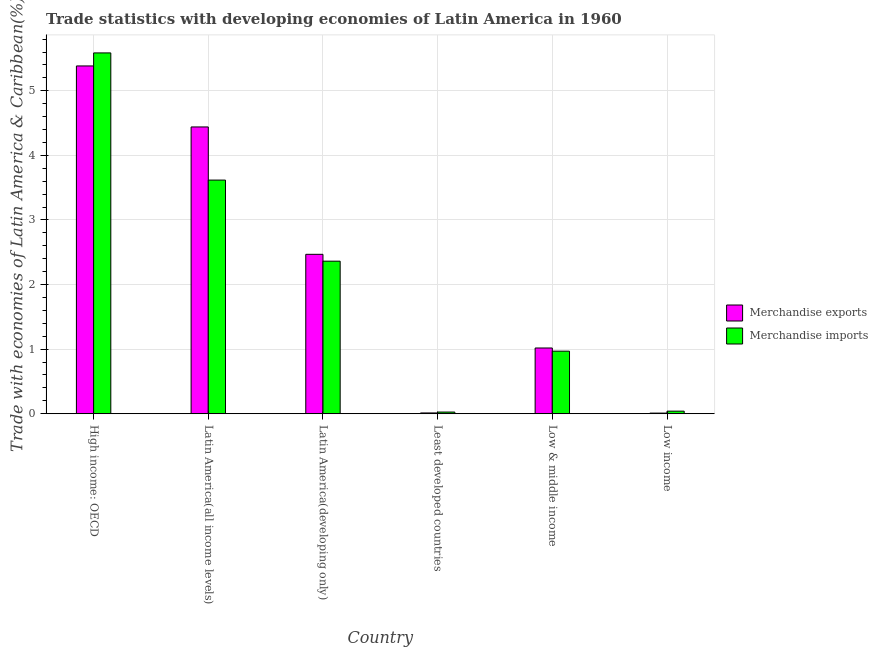Are the number of bars on each tick of the X-axis equal?
Provide a short and direct response. Yes. What is the label of the 5th group of bars from the left?
Your answer should be very brief. Low & middle income. In how many cases, is the number of bars for a given country not equal to the number of legend labels?
Give a very brief answer. 0. What is the merchandise imports in Least developed countries?
Offer a very short reply. 0.03. Across all countries, what is the maximum merchandise exports?
Your answer should be very brief. 5.38. Across all countries, what is the minimum merchandise imports?
Offer a terse response. 0.03. In which country was the merchandise imports maximum?
Your response must be concise. High income: OECD. In which country was the merchandise imports minimum?
Your response must be concise. Least developed countries. What is the total merchandise exports in the graph?
Provide a succinct answer. 13.33. What is the difference between the merchandise exports in Least developed countries and that in Low & middle income?
Your response must be concise. -1.01. What is the difference between the merchandise imports in Low income and the merchandise exports in Low & middle income?
Your answer should be very brief. -0.98. What is the average merchandise imports per country?
Make the answer very short. 2.1. What is the difference between the merchandise imports and merchandise exports in Low & middle income?
Ensure brevity in your answer.  -0.05. What is the ratio of the merchandise exports in Latin America(all income levels) to that in Low income?
Offer a very short reply. 452.83. Is the difference between the merchandise exports in Latin America(all income levels) and Least developed countries greater than the difference between the merchandise imports in Latin America(all income levels) and Least developed countries?
Your response must be concise. Yes. What is the difference between the highest and the second highest merchandise imports?
Provide a succinct answer. 1.97. What is the difference between the highest and the lowest merchandise exports?
Offer a terse response. 5.37. Is the sum of the merchandise exports in High income: OECD and Least developed countries greater than the maximum merchandise imports across all countries?
Your response must be concise. No. What does the 1st bar from the right in Low income represents?
Offer a terse response. Merchandise imports. What is the difference between two consecutive major ticks on the Y-axis?
Your answer should be compact. 1. Where does the legend appear in the graph?
Keep it short and to the point. Center right. How many legend labels are there?
Offer a very short reply. 2. What is the title of the graph?
Give a very brief answer. Trade statistics with developing economies of Latin America in 1960. What is the label or title of the X-axis?
Provide a short and direct response. Country. What is the label or title of the Y-axis?
Offer a terse response. Trade with economies of Latin America & Caribbean(%). What is the Trade with economies of Latin America & Caribbean(%) in Merchandise exports in High income: OECD?
Give a very brief answer. 5.38. What is the Trade with economies of Latin America & Caribbean(%) of Merchandise imports in High income: OECD?
Your answer should be compact. 5.59. What is the Trade with economies of Latin America & Caribbean(%) in Merchandise exports in Latin America(all income levels)?
Your answer should be compact. 4.44. What is the Trade with economies of Latin America & Caribbean(%) in Merchandise imports in Latin America(all income levels)?
Your response must be concise. 3.62. What is the Trade with economies of Latin America & Caribbean(%) of Merchandise exports in Latin America(developing only)?
Your answer should be very brief. 2.47. What is the Trade with economies of Latin America & Caribbean(%) in Merchandise imports in Latin America(developing only)?
Offer a very short reply. 2.36. What is the Trade with economies of Latin America & Caribbean(%) of Merchandise exports in Least developed countries?
Keep it short and to the point. 0.01. What is the Trade with economies of Latin America & Caribbean(%) of Merchandise imports in Least developed countries?
Make the answer very short. 0.03. What is the Trade with economies of Latin America & Caribbean(%) in Merchandise exports in Low & middle income?
Ensure brevity in your answer.  1.02. What is the Trade with economies of Latin America & Caribbean(%) of Merchandise imports in Low & middle income?
Provide a short and direct response. 0.97. What is the Trade with economies of Latin America & Caribbean(%) of Merchandise exports in Low income?
Keep it short and to the point. 0.01. What is the Trade with economies of Latin America & Caribbean(%) of Merchandise imports in Low income?
Offer a terse response. 0.04. Across all countries, what is the maximum Trade with economies of Latin America & Caribbean(%) in Merchandise exports?
Your answer should be very brief. 5.38. Across all countries, what is the maximum Trade with economies of Latin America & Caribbean(%) in Merchandise imports?
Provide a succinct answer. 5.59. Across all countries, what is the minimum Trade with economies of Latin America & Caribbean(%) in Merchandise exports?
Provide a short and direct response. 0.01. Across all countries, what is the minimum Trade with economies of Latin America & Caribbean(%) in Merchandise imports?
Your answer should be compact. 0.03. What is the total Trade with economies of Latin America & Caribbean(%) of Merchandise exports in the graph?
Your response must be concise. 13.33. What is the total Trade with economies of Latin America & Caribbean(%) in Merchandise imports in the graph?
Ensure brevity in your answer.  12.6. What is the difference between the Trade with economies of Latin America & Caribbean(%) of Merchandise exports in High income: OECD and that in Latin America(all income levels)?
Offer a very short reply. 0.94. What is the difference between the Trade with economies of Latin America & Caribbean(%) in Merchandise imports in High income: OECD and that in Latin America(all income levels)?
Provide a short and direct response. 1.97. What is the difference between the Trade with economies of Latin America & Caribbean(%) of Merchandise exports in High income: OECD and that in Latin America(developing only)?
Give a very brief answer. 2.92. What is the difference between the Trade with economies of Latin America & Caribbean(%) in Merchandise imports in High income: OECD and that in Latin America(developing only)?
Provide a short and direct response. 3.22. What is the difference between the Trade with economies of Latin America & Caribbean(%) in Merchandise exports in High income: OECD and that in Least developed countries?
Provide a short and direct response. 5.37. What is the difference between the Trade with economies of Latin America & Caribbean(%) in Merchandise imports in High income: OECD and that in Least developed countries?
Ensure brevity in your answer.  5.56. What is the difference between the Trade with economies of Latin America & Caribbean(%) in Merchandise exports in High income: OECD and that in Low & middle income?
Your answer should be compact. 4.37. What is the difference between the Trade with economies of Latin America & Caribbean(%) in Merchandise imports in High income: OECD and that in Low & middle income?
Ensure brevity in your answer.  4.62. What is the difference between the Trade with economies of Latin America & Caribbean(%) in Merchandise exports in High income: OECD and that in Low income?
Give a very brief answer. 5.37. What is the difference between the Trade with economies of Latin America & Caribbean(%) in Merchandise imports in High income: OECD and that in Low income?
Offer a very short reply. 5.55. What is the difference between the Trade with economies of Latin America & Caribbean(%) in Merchandise exports in Latin America(all income levels) and that in Latin America(developing only)?
Your answer should be very brief. 1.97. What is the difference between the Trade with economies of Latin America & Caribbean(%) in Merchandise imports in Latin America(all income levels) and that in Latin America(developing only)?
Your answer should be very brief. 1.26. What is the difference between the Trade with economies of Latin America & Caribbean(%) of Merchandise exports in Latin America(all income levels) and that in Least developed countries?
Offer a terse response. 4.43. What is the difference between the Trade with economies of Latin America & Caribbean(%) of Merchandise imports in Latin America(all income levels) and that in Least developed countries?
Ensure brevity in your answer.  3.59. What is the difference between the Trade with economies of Latin America & Caribbean(%) of Merchandise exports in Latin America(all income levels) and that in Low & middle income?
Your response must be concise. 3.42. What is the difference between the Trade with economies of Latin America & Caribbean(%) in Merchandise imports in Latin America(all income levels) and that in Low & middle income?
Offer a very short reply. 2.65. What is the difference between the Trade with economies of Latin America & Caribbean(%) in Merchandise exports in Latin America(all income levels) and that in Low income?
Provide a short and direct response. 4.43. What is the difference between the Trade with economies of Latin America & Caribbean(%) of Merchandise imports in Latin America(all income levels) and that in Low income?
Your answer should be compact. 3.58. What is the difference between the Trade with economies of Latin America & Caribbean(%) in Merchandise exports in Latin America(developing only) and that in Least developed countries?
Your response must be concise. 2.46. What is the difference between the Trade with economies of Latin America & Caribbean(%) in Merchandise imports in Latin America(developing only) and that in Least developed countries?
Give a very brief answer. 2.34. What is the difference between the Trade with economies of Latin America & Caribbean(%) of Merchandise exports in Latin America(developing only) and that in Low & middle income?
Your answer should be very brief. 1.45. What is the difference between the Trade with economies of Latin America & Caribbean(%) of Merchandise imports in Latin America(developing only) and that in Low & middle income?
Your answer should be compact. 1.39. What is the difference between the Trade with economies of Latin America & Caribbean(%) of Merchandise exports in Latin America(developing only) and that in Low income?
Your answer should be compact. 2.46. What is the difference between the Trade with economies of Latin America & Caribbean(%) of Merchandise imports in Latin America(developing only) and that in Low income?
Offer a very short reply. 2.32. What is the difference between the Trade with economies of Latin America & Caribbean(%) of Merchandise exports in Least developed countries and that in Low & middle income?
Your response must be concise. -1.01. What is the difference between the Trade with economies of Latin America & Caribbean(%) in Merchandise imports in Least developed countries and that in Low & middle income?
Make the answer very short. -0.94. What is the difference between the Trade with economies of Latin America & Caribbean(%) in Merchandise exports in Least developed countries and that in Low income?
Provide a succinct answer. 0. What is the difference between the Trade with economies of Latin America & Caribbean(%) of Merchandise imports in Least developed countries and that in Low income?
Offer a very short reply. -0.01. What is the difference between the Trade with economies of Latin America & Caribbean(%) in Merchandise imports in Low & middle income and that in Low income?
Make the answer very short. 0.93. What is the difference between the Trade with economies of Latin America & Caribbean(%) in Merchandise exports in High income: OECD and the Trade with economies of Latin America & Caribbean(%) in Merchandise imports in Latin America(all income levels)?
Your response must be concise. 1.77. What is the difference between the Trade with economies of Latin America & Caribbean(%) in Merchandise exports in High income: OECD and the Trade with economies of Latin America & Caribbean(%) in Merchandise imports in Latin America(developing only)?
Give a very brief answer. 3.02. What is the difference between the Trade with economies of Latin America & Caribbean(%) in Merchandise exports in High income: OECD and the Trade with economies of Latin America & Caribbean(%) in Merchandise imports in Least developed countries?
Make the answer very short. 5.36. What is the difference between the Trade with economies of Latin America & Caribbean(%) in Merchandise exports in High income: OECD and the Trade with economies of Latin America & Caribbean(%) in Merchandise imports in Low & middle income?
Offer a very short reply. 4.42. What is the difference between the Trade with economies of Latin America & Caribbean(%) in Merchandise exports in High income: OECD and the Trade with economies of Latin America & Caribbean(%) in Merchandise imports in Low income?
Your response must be concise. 5.34. What is the difference between the Trade with economies of Latin America & Caribbean(%) of Merchandise exports in Latin America(all income levels) and the Trade with economies of Latin America & Caribbean(%) of Merchandise imports in Latin America(developing only)?
Offer a very short reply. 2.08. What is the difference between the Trade with economies of Latin America & Caribbean(%) of Merchandise exports in Latin America(all income levels) and the Trade with economies of Latin America & Caribbean(%) of Merchandise imports in Least developed countries?
Your response must be concise. 4.41. What is the difference between the Trade with economies of Latin America & Caribbean(%) of Merchandise exports in Latin America(all income levels) and the Trade with economies of Latin America & Caribbean(%) of Merchandise imports in Low & middle income?
Give a very brief answer. 3.47. What is the difference between the Trade with economies of Latin America & Caribbean(%) of Merchandise exports in Latin America(all income levels) and the Trade with economies of Latin America & Caribbean(%) of Merchandise imports in Low income?
Offer a terse response. 4.4. What is the difference between the Trade with economies of Latin America & Caribbean(%) in Merchandise exports in Latin America(developing only) and the Trade with economies of Latin America & Caribbean(%) in Merchandise imports in Least developed countries?
Your response must be concise. 2.44. What is the difference between the Trade with economies of Latin America & Caribbean(%) in Merchandise exports in Latin America(developing only) and the Trade with economies of Latin America & Caribbean(%) in Merchandise imports in Low & middle income?
Provide a short and direct response. 1.5. What is the difference between the Trade with economies of Latin America & Caribbean(%) of Merchandise exports in Latin America(developing only) and the Trade with economies of Latin America & Caribbean(%) of Merchandise imports in Low income?
Give a very brief answer. 2.43. What is the difference between the Trade with economies of Latin America & Caribbean(%) in Merchandise exports in Least developed countries and the Trade with economies of Latin America & Caribbean(%) in Merchandise imports in Low & middle income?
Give a very brief answer. -0.96. What is the difference between the Trade with economies of Latin America & Caribbean(%) in Merchandise exports in Least developed countries and the Trade with economies of Latin America & Caribbean(%) in Merchandise imports in Low income?
Keep it short and to the point. -0.03. What is the difference between the Trade with economies of Latin America & Caribbean(%) of Merchandise exports in Low & middle income and the Trade with economies of Latin America & Caribbean(%) of Merchandise imports in Low income?
Offer a very short reply. 0.98. What is the average Trade with economies of Latin America & Caribbean(%) in Merchandise exports per country?
Your answer should be very brief. 2.22. What is the difference between the Trade with economies of Latin America & Caribbean(%) of Merchandise exports and Trade with economies of Latin America & Caribbean(%) of Merchandise imports in High income: OECD?
Offer a terse response. -0.2. What is the difference between the Trade with economies of Latin America & Caribbean(%) in Merchandise exports and Trade with economies of Latin America & Caribbean(%) in Merchandise imports in Latin America(all income levels)?
Provide a succinct answer. 0.82. What is the difference between the Trade with economies of Latin America & Caribbean(%) of Merchandise exports and Trade with economies of Latin America & Caribbean(%) of Merchandise imports in Latin America(developing only)?
Your answer should be compact. 0.11. What is the difference between the Trade with economies of Latin America & Caribbean(%) of Merchandise exports and Trade with economies of Latin America & Caribbean(%) of Merchandise imports in Least developed countries?
Ensure brevity in your answer.  -0.01. What is the difference between the Trade with economies of Latin America & Caribbean(%) in Merchandise exports and Trade with economies of Latin America & Caribbean(%) in Merchandise imports in Low & middle income?
Keep it short and to the point. 0.05. What is the difference between the Trade with economies of Latin America & Caribbean(%) in Merchandise exports and Trade with economies of Latin America & Caribbean(%) in Merchandise imports in Low income?
Your answer should be very brief. -0.03. What is the ratio of the Trade with economies of Latin America & Caribbean(%) of Merchandise exports in High income: OECD to that in Latin America(all income levels)?
Provide a succinct answer. 1.21. What is the ratio of the Trade with economies of Latin America & Caribbean(%) in Merchandise imports in High income: OECD to that in Latin America(all income levels)?
Keep it short and to the point. 1.54. What is the ratio of the Trade with economies of Latin America & Caribbean(%) in Merchandise exports in High income: OECD to that in Latin America(developing only)?
Provide a succinct answer. 2.18. What is the ratio of the Trade with economies of Latin America & Caribbean(%) of Merchandise imports in High income: OECD to that in Latin America(developing only)?
Offer a very short reply. 2.37. What is the ratio of the Trade with economies of Latin America & Caribbean(%) in Merchandise exports in High income: OECD to that in Least developed countries?
Your answer should be very brief. 436.17. What is the ratio of the Trade with economies of Latin America & Caribbean(%) of Merchandise imports in High income: OECD to that in Least developed countries?
Your response must be concise. 214.16. What is the ratio of the Trade with economies of Latin America & Caribbean(%) of Merchandise exports in High income: OECD to that in Low & middle income?
Your answer should be compact. 5.29. What is the ratio of the Trade with economies of Latin America & Caribbean(%) of Merchandise imports in High income: OECD to that in Low & middle income?
Ensure brevity in your answer.  5.77. What is the ratio of the Trade with economies of Latin America & Caribbean(%) of Merchandise exports in High income: OECD to that in Low income?
Provide a succinct answer. 549.16. What is the ratio of the Trade with economies of Latin America & Caribbean(%) in Merchandise imports in High income: OECD to that in Low income?
Your response must be concise. 138.92. What is the ratio of the Trade with economies of Latin America & Caribbean(%) in Merchandise exports in Latin America(all income levels) to that in Latin America(developing only)?
Ensure brevity in your answer.  1.8. What is the ratio of the Trade with economies of Latin America & Caribbean(%) of Merchandise imports in Latin America(all income levels) to that in Latin America(developing only)?
Your answer should be very brief. 1.53. What is the ratio of the Trade with economies of Latin America & Caribbean(%) in Merchandise exports in Latin America(all income levels) to that in Least developed countries?
Offer a very short reply. 359.66. What is the ratio of the Trade with economies of Latin America & Caribbean(%) in Merchandise imports in Latin America(all income levels) to that in Least developed countries?
Ensure brevity in your answer.  138.68. What is the ratio of the Trade with economies of Latin America & Caribbean(%) in Merchandise exports in Latin America(all income levels) to that in Low & middle income?
Give a very brief answer. 4.36. What is the ratio of the Trade with economies of Latin America & Caribbean(%) in Merchandise imports in Latin America(all income levels) to that in Low & middle income?
Your answer should be very brief. 3.73. What is the ratio of the Trade with economies of Latin America & Caribbean(%) in Merchandise exports in Latin America(all income levels) to that in Low income?
Your answer should be compact. 452.83. What is the ratio of the Trade with economies of Latin America & Caribbean(%) of Merchandise imports in Latin America(all income levels) to that in Low income?
Give a very brief answer. 89.96. What is the ratio of the Trade with economies of Latin America & Caribbean(%) in Merchandise exports in Latin America(developing only) to that in Least developed countries?
Your response must be concise. 199.93. What is the ratio of the Trade with economies of Latin America & Caribbean(%) of Merchandise imports in Latin America(developing only) to that in Least developed countries?
Your answer should be very brief. 90.55. What is the ratio of the Trade with economies of Latin America & Caribbean(%) of Merchandise exports in Latin America(developing only) to that in Low & middle income?
Make the answer very short. 2.42. What is the ratio of the Trade with economies of Latin America & Caribbean(%) of Merchandise imports in Latin America(developing only) to that in Low & middle income?
Keep it short and to the point. 2.44. What is the ratio of the Trade with economies of Latin America & Caribbean(%) in Merchandise exports in Latin America(developing only) to that in Low income?
Give a very brief answer. 251.73. What is the ratio of the Trade with economies of Latin America & Caribbean(%) of Merchandise imports in Latin America(developing only) to that in Low income?
Make the answer very short. 58.74. What is the ratio of the Trade with economies of Latin America & Caribbean(%) in Merchandise exports in Least developed countries to that in Low & middle income?
Keep it short and to the point. 0.01. What is the ratio of the Trade with economies of Latin America & Caribbean(%) in Merchandise imports in Least developed countries to that in Low & middle income?
Give a very brief answer. 0.03. What is the ratio of the Trade with economies of Latin America & Caribbean(%) in Merchandise exports in Least developed countries to that in Low income?
Offer a terse response. 1.26. What is the ratio of the Trade with economies of Latin America & Caribbean(%) of Merchandise imports in Least developed countries to that in Low income?
Your answer should be very brief. 0.65. What is the ratio of the Trade with economies of Latin America & Caribbean(%) of Merchandise exports in Low & middle income to that in Low income?
Ensure brevity in your answer.  103.82. What is the ratio of the Trade with economies of Latin America & Caribbean(%) of Merchandise imports in Low & middle income to that in Low income?
Your answer should be very brief. 24.09. What is the difference between the highest and the second highest Trade with economies of Latin America & Caribbean(%) in Merchandise exports?
Offer a terse response. 0.94. What is the difference between the highest and the second highest Trade with economies of Latin America & Caribbean(%) of Merchandise imports?
Provide a short and direct response. 1.97. What is the difference between the highest and the lowest Trade with economies of Latin America & Caribbean(%) in Merchandise exports?
Keep it short and to the point. 5.37. What is the difference between the highest and the lowest Trade with economies of Latin America & Caribbean(%) in Merchandise imports?
Your answer should be compact. 5.56. 